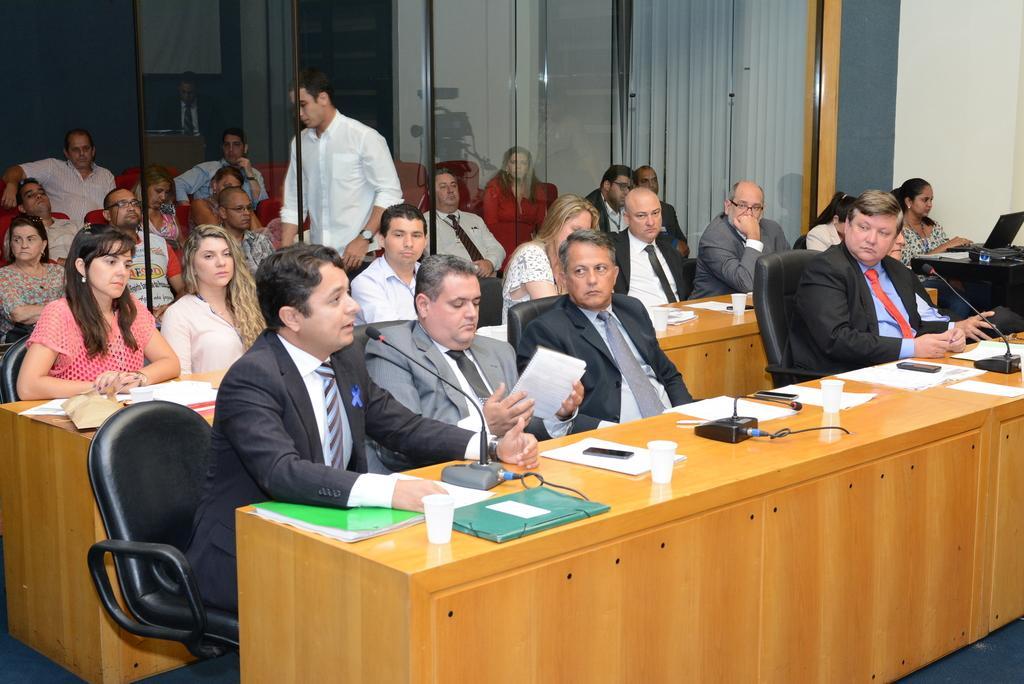Could you give a brief overview of what you see in this image? In this picture we can observe some people sitting in the chairs in front of the cream color table on which we can observe some glasses, papers, mobiles and mics. There are men and women in this picture. On the right side we can observe a laptop on the black color table. In the background there is a white color curtain and a wall. 